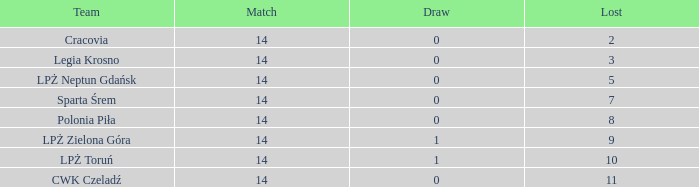Would you be able to parse every entry in this table? {'header': ['Team', 'Match', 'Draw', 'Lost'], 'rows': [['Cracovia', '14', '0', '2'], ['Legia Krosno', '14', '0', '3'], ['LPŻ Neptun Gdańsk', '14', '0', '5'], ['Sparta Śrem', '14', '0', '7'], ['Polonia Piła', '14', '0', '8'], ['LPŻ Zielona Góra', '14', '1', '9'], ['LPŻ Toruń', '14', '1', '10'], ['CWK Czeladź', '14', '0', '11']]} What is the lowest points for a match before 14? None. 